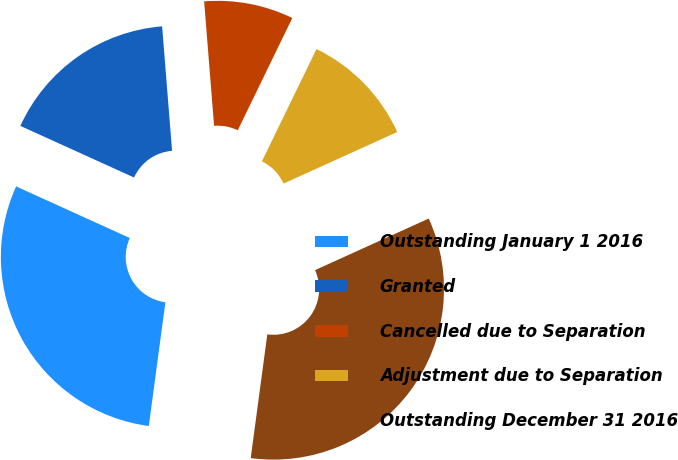Convert chart. <chart><loc_0><loc_0><loc_500><loc_500><pie_chart><fcel>Outstanding January 1 2016<fcel>Granted<fcel>Cancelled due to Separation<fcel>Adjustment due to Separation<fcel>Outstanding December 31 2016<nl><fcel>29.66%<fcel>16.95%<fcel>8.47%<fcel>11.02%<fcel>33.9%<nl></chart> 